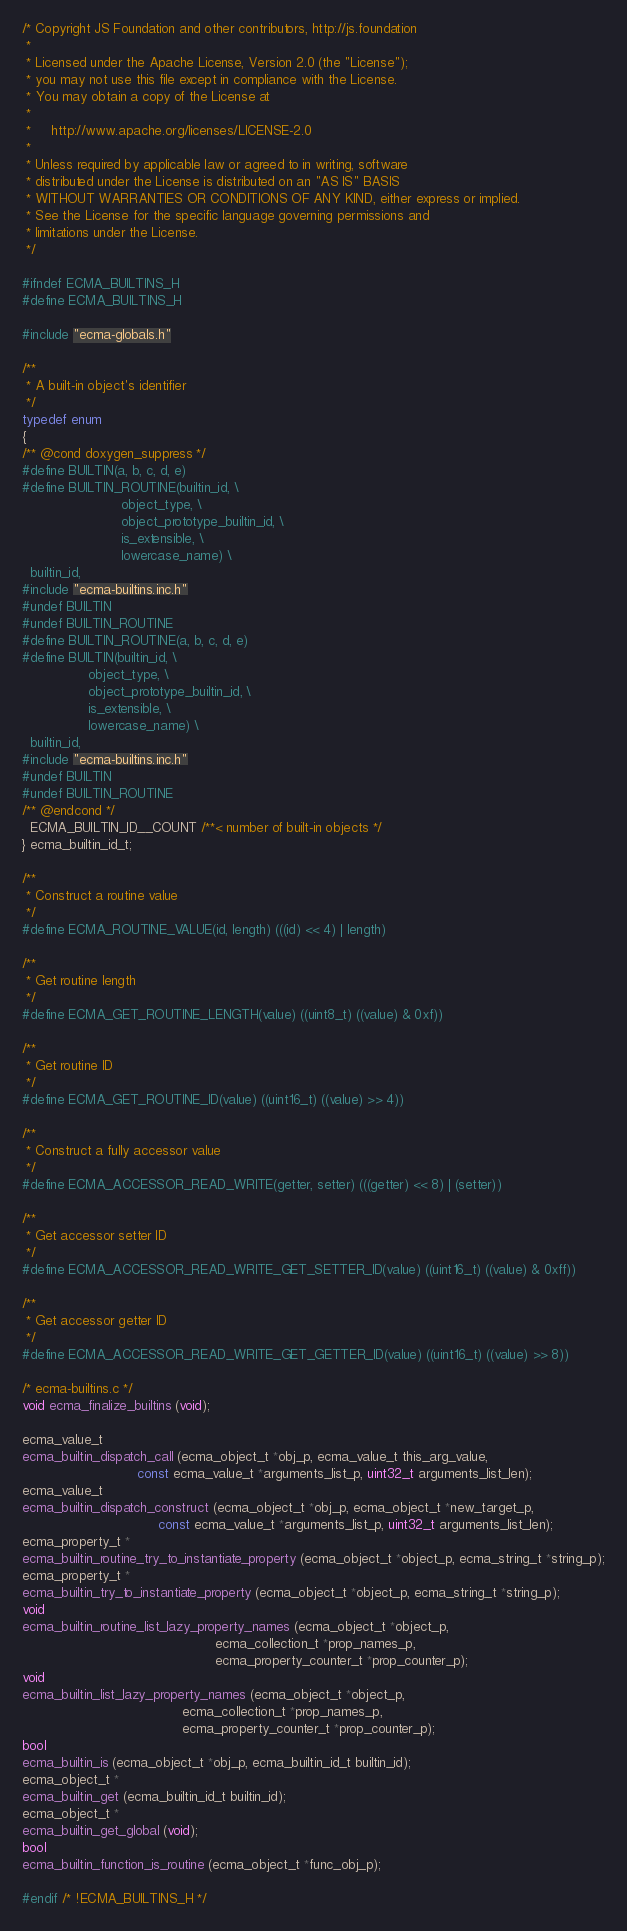Convert code to text. <code><loc_0><loc_0><loc_500><loc_500><_C_>/* Copyright JS Foundation and other contributors, http://js.foundation
 *
 * Licensed under the Apache License, Version 2.0 (the "License");
 * you may not use this file except in compliance with the License.
 * You may obtain a copy of the License at
 *
 *     http://www.apache.org/licenses/LICENSE-2.0
 *
 * Unless required by applicable law or agreed to in writing, software
 * distributed under the License is distributed on an "AS IS" BASIS
 * WITHOUT WARRANTIES OR CONDITIONS OF ANY KIND, either express or implied.
 * See the License for the specific language governing permissions and
 * limitations under the License.
 */

#ifndef ECMA_BUILTINS_H
#define ECMA_BUILTINS_H

#include "ecma-globals.h"

/**
 * A built-in object's identifier
 */
typedef enum
{
/** @cond doxygen_suppress */
#define BUILTIN(a, b, c, d, e)
#define BUILTIN_ROUTINE(builtin_id, \
                        object_type, \
                        object_prototype_builtin_id, \
                        is_extensible, \
                        lowercase_name) \
  builtin_id,
#include "ecma-builtins.inc.h"
#undef BUILTIN
#undef BUILTIN_ROUTINE
#define BUILTIN_ROUTINE(a, b, c, d, e)
#define BUILTIN(builtin_id, \
                object_type, \
                object_prototype_builtin_id, \
                is_extensible, \
                lowercase_name) \
  builtin_id,
#include "ecma-builtins.inc.h"
#undef BUILTIN
#undef BUILTIN_ROUTINE
/** @endcond */
  ECMA_BUILTIN_ID__COUNT /**< number of built-in objects */
} ecma_builtin_id_t;

/**
 * Construct a routine value
 */
#define ECMA_ROUTINE_VALUE(id, length) (((id) << 4) | length)

/**
 * Get routine length
 */
#define ECMA_GET_ROUTINE_LENGTH(value) ((uint8_t) ((value) & 0xf))

/**
 * Get routine ID
 */
#define ECMA_GET_ROUTINE_ID(value) ((uint16_t) ((value) >> 4))

/**
 * Construct a fully accessor value
 */
#define ECMA_ACCESSOR_READ_WRITE(getter, setter) (((getter) << 8) | (setter))

/**
 * Get accessor setter ID
 */
#define ECMA_ACCESSOR_READ_WRITE_GET_SETTER_ID(value) ((uint16_t) ((value) & 0xff))

/**
 * Get accessor getter ID
 */
#define ECMA_ACCESSOR_READ_WRITE_GET_GETTER_ID(value) ((uint16_t) ((value) >> 8))

/* ecma-builtins.c */
void ecma_finalize_builtins (void);

ecma_value_t
ecma_builtin_dispatch_call (ecma_object_t *obj_p, ecma_value_t this_arg_value,
                            const ecma_value_t *arguments_list_p, uint32_t arguments_list_len);
ecma_value_t
ecma_builtin_dispatch_construct (ecma_object_t *obj_p, ecma_object_t *new_target_p,
                                 const ecma_value_t *arguments_list_p, uint32_t arguments_list_len);
ecma_property_t *
ecma_builtin_routine_try_to_instantiate_property (ecma_object_t *object_p, ecma_string_t *string_p);
ecma_property_t *
ecma_builtin_try_to_instantiate_property (ecma_object_t *object_p, ecma_string_t *string_p);
void
ecma_builtin_routine_list_lazy_property_names (ecma_object_t *object_p,
                                               ecma_collection_t *prop_names_p,
                                               ecma_property_counter_t *prop_counter_p);
void
ecma_builtin_list_lazy_property_names (ecma_object_t *object_p,
                                       ecma_collection_t *prop_names_p,
                                       ecma_property_counter_t *prop_counter_p);
bool
ecma_builtin_is (ecma_object_t *obj_p, ecma_builtin_id_t builtin_id);
ecma_object_t *
ecma_builtin_get (ecma_builtin_id_t builtin_id);
ecma_object_t *
ecma_builtin_get_global (void);
bool
ecma_builtin_function_is_routine (ecma_object_t *func_obj_p);

#endif /* !ECMA_BUILTINS_H */
</code> 